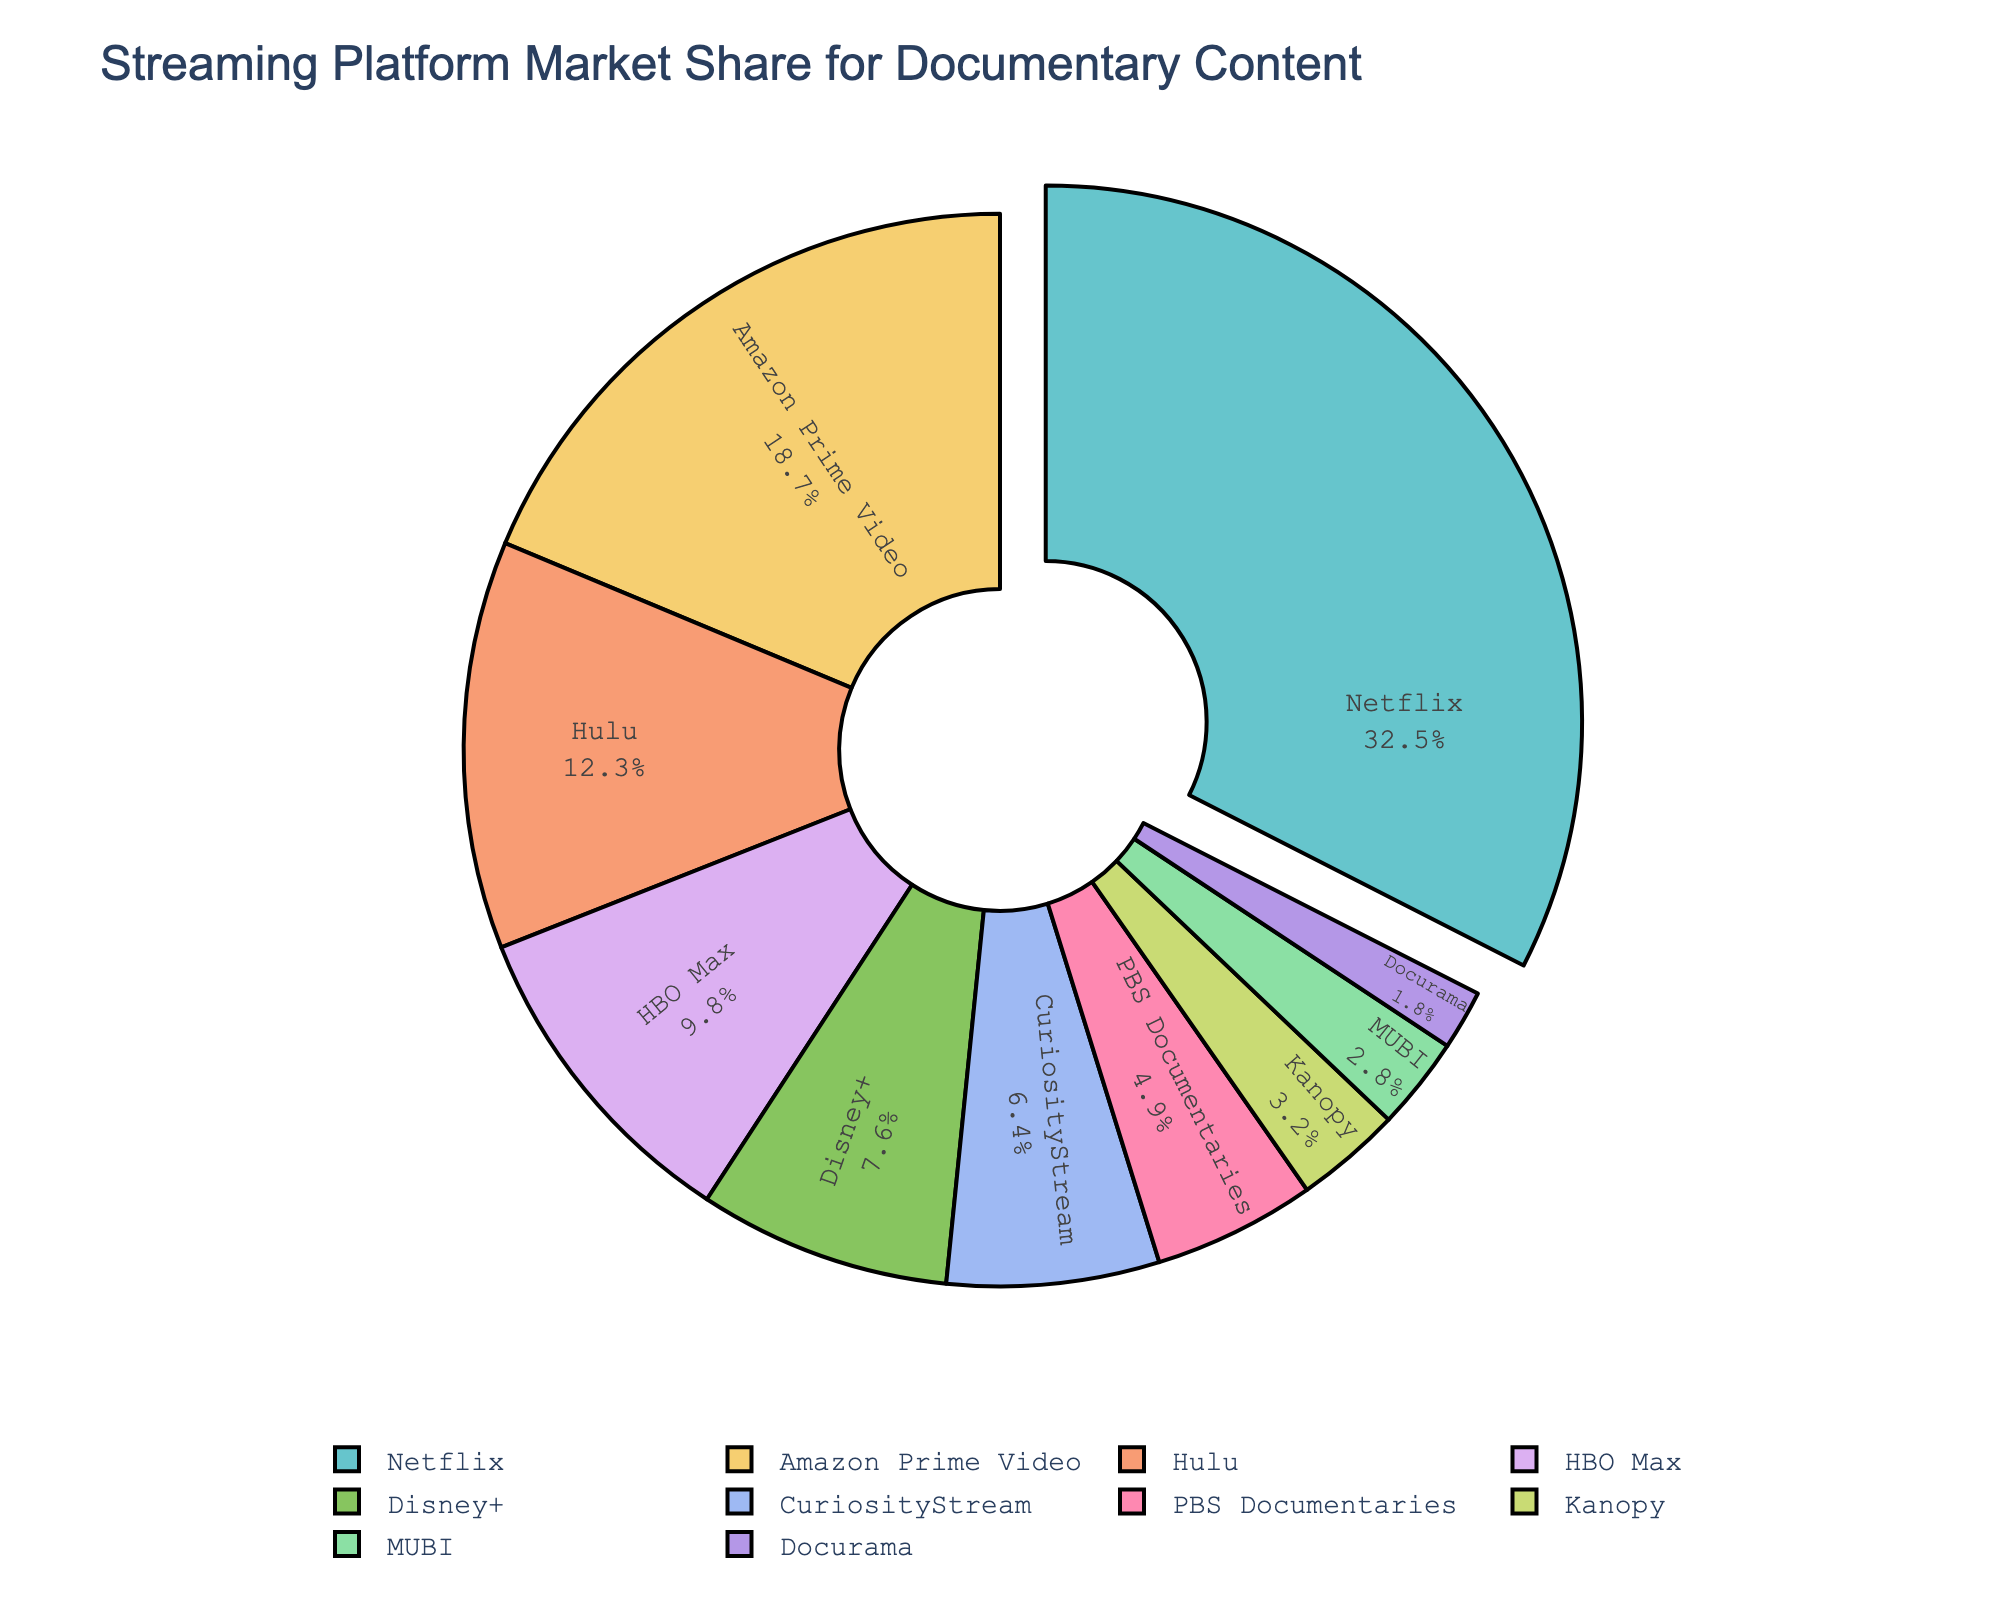Which streaming platform has the largest market share for documentary content? The pie chart shows various streaming platforms and their respective market shares. The platform with the largest section of the pie chart is Netflix.
Answer: Netflix What is the combined market share of Netflix and Amazon Prime Video? To find the combined market share, sum the market shares of Netflix (32.5%) and Amazon Prime Video (18.7%). So, 32.5 + 18.7 = 51.2.
Answer: 51.2% Which streaming platform has a market share closest to 10%? The pie chart indicates that HBO Max has a market share of 9.8%, which is closest to 10%.
Answer: HBO Max By how much does Hulu's market share exceed that of Kanopy? To find the difference, subtract Kanopy's market share (3.2%) from Hulu's market share (12.3%). So, 12.3 - 3.2 = 9.1.
Answer: 9.1% Which platforms have a market share below 5%? The pie chart segments indicate that PBS Documentaries (4.9%), Kanopy (3.2%), MUBI (2.8%), and Docurama (1.8%) have market shares below 5%.
Answer: PBS Documentaries, Kanopy, MUBI, Docurama What is the total market share of the platforms with less than 10% each? Sum the market shares of HBO Max (9.8%), Disney+ (7.6%), CuriosityStream (6.4%), PBS Documentaries (4.9%), Kanopy (3.2%), MUBI (2.8%), and Docurama (1.8%). Total = 9.8 + 7.6 + 6.4 + 4.9 + 3.2 + 2.8 + 1.8 = 36.5.
Answer: 36.5% Which platform’s market share is highlighted or visually emphasized in the pie chart? The pie chart has a segment pulled out which indicates the emphasized platform. The platform with the largest share, Netflix, is pulled out for emphasis.
Answer: Netflix What is the average market share of Disney+, CuriosityStream, and PBS Documentaries? First, sum their market shares: Disney+ (7.6%), CuriosityStream (6.4%), PBS Documentaries (4.9%). So, 7.6 + 6.4 + 4.9 = 18.9. Then, divide by the number of platforms (3). So, 18.9/3 = 6.3.
Answer: 6.3% Which streaming platform's market share is represented by the lightest color in the pie chart? In the pie chart, the visual attribute indicates that Docurama, the smallest segment, is represented by the lightest color.
Answer: Docurama Compare the market share of HBO Max and Disney+. Which one is greater and by how much? To compare, subtract Disney+'s market share (7.6%) from HBO Max's market share (9.8%). So, 9.8 - 7.6 = 2.2. HBO Max has the greater market share by 2.2%.
Answer: HBO Max by 2.2% 